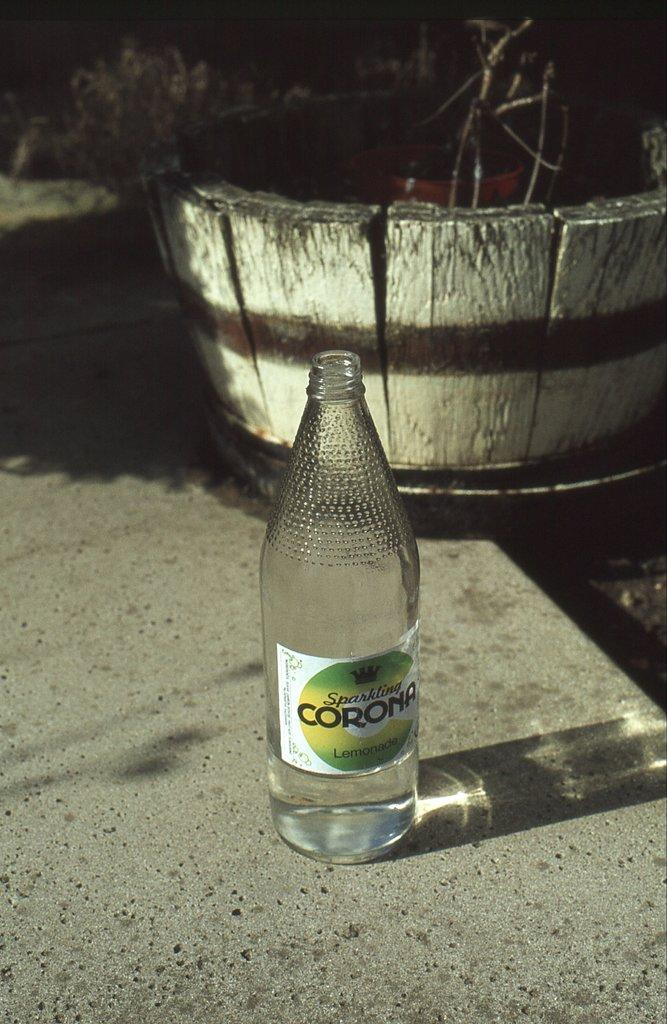<image>
Provide a brief description of the given image. A bottle of Corona sits on the pavement empty. 